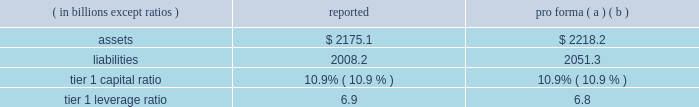Notes to consolidated financial statements 192 jpmorgan chase & co .
/ 2008 annual report consolidation analysis the multi-seller conduits administered by the firm were not consoli- dated at december 31 , 2008 and 2007 , because each conduit had issued expected loss notes ( 201celns 201d ) , the holders of which are com- mitted to absorbing the majority of the expected loss of each respective conduit .
Implied support the firm did not have and continues not to have any intent to pro- tect any eln holders from potential losses on any of the conduits 2019 holdings and has no plans to remove any assets from any conduit unless required to do so in its role as administrator .
Should such a transfer occur , the firm would allocate losses on such assets between itself and the eln holders in accordance with the terms of the applicable eln .
Expected loss modeling in determining the primary beneficiary of the conduits the firm uses a monte carlo 2013based model to estimate the expected losses of each of the conduits and considers the relative rights and obliga- tions of each of the variable interest holders .
The firm 2019s expected loss modeling treats all variable interests , other than the elns , as its own to determine consolidation .
The variability to be considered in the modeling of expected losses is based on the design of the enti- ty .
The firm 2019s traditional multi-seller conduits are designed to pass credit risk , not liquidity risk , to its variable interest holders , as the assets are intended to be held in the conduit for the longer term .
Under fin 46 ( r ) , the firm is required to run the monte carlo-based expected loss model each time a reconsideration event occurs .
In applying this guidance to the conduits , the following events , are considered to be reconsideration events , as they could affect the determination of the primary beneficiary of the conduits : 2022 new deals , including the issuance of new or additional variable interests ( credit support , liquidity facilities , etc ) ; 2022 changes in usage , including the change in the level of outstand- ing variable interests ( credit support , liquidity facilities , etc ) ; 2022 modifications of asset purchase agreements ; and 2022 sales of interests held by the primary beneficiary .
From an operational perspective , the firm does not run its monte carlo-based expected loss model every time there is a reconsideration event due to the frequency of their occurrence .
Instead , the firm runs its expected loss model each quarter and includes a growth assump- tion for each conduit to ensure that a sufficient amount of elns exists for each conduit at any point during the quarter .
As part of its normal quarterly modeling , the firm updates , when applicable , the inputs and assumptions used in the expected loss model .
Specifically , risk ratings and loss given default assumptions are continually updated .
The total amount of expected loss notes out- standing at december 31 , 2008 and 2007 , were $ 136 million and $ 130 million , respectively .
Management has concluded that the model assumptions used were reflective of market participants 2019 assumptions and appropriately considered the probability of changes to risk ratings and loss given defaults .
Qualitative considerations the multi-seller conduits are primarily designed to provide an effi- cient means for clients to access the commercial paper market .
The firm believes the conduits effectively disperse risk among all parties and that the preponderance of the economic risk in the firm 2019s multi- seller conduits is not held by jpmorgan chase .
Consolidated sensitivity analysis on capital the table below shows the impact on the firm 2019s reported assets , lia- bilities , tier 1 capital ratio and tier 1 leverage ratio if the firm were required to consolidate all of the multi-seller conduits that it admin- isters at their current carrying value .
December 31 , 2008 ( in billions , except ratios ) reported pro forma ( a ) ( b ) .
( a ) the table shows the impact of consolidating the assets and liabilities of the multi- seller conduits at their current carrying value ; as such , there would be no income statement or capital impact at the date of consolidation .
If the firm were required to consolidate the assets and liabilities of the conduits at fair value , the tier 1 capital ratio would be approximately 10.8% ( 10.8 % ) .
The fair value of the assets is primarily based upon pricing for comparable transactions .
The fair value of these assets could change significantly because the pricing of conduit transactions is renegotiated with the client , generally , on an annual basis and due to changes in current market conditions .
( b ) consolidation is assumed to occur on the first day of the quarter , at the quarter-end levels , in order to provide a meaningful adjustment to average assets in the denomi- nator of the leverage ratio .
The firm could fund purchases of assets from vies should it become necessary .
2007 activity in july 2007 , a reverse repurchase agreement collateralized by prime residential mortgages held by a firm-administered multi-seller conduit was put to jpmorgan chase under its deal-specific liquidity facility .
The asset was transferred to and recorded by jpmorgan chase at its par value based on the fair value of the collateral that supported the reverse repurchase agreement .
During the fourth quarter of 2007 , additional information regarding the value of the collateral , including performance statistics , resulted in the determi- nation by the firm that the fair value of the collateral was impaired .
Impairment losses were allocated to the eln holder ( the party that absorbs the majority of the expected loss from the conduit ) in accor- dance with the contractual provisions of the eln note .
On october 29 , 2007 , certain structured cdo assets originated in the second quarter of 2007 and backed by subprime mortgages were transferred to the firm from two firm-administered multi-seller conduits .
It became clear in october that commercial paper investors and rating agencies were becoming increasingly concerned about cdo assets backed by subprime mortgage exposures .
Because of these concerns , and to ensure the continuing viability of the two conduits as financing vehicles for clients and as investment alternatives for commercial paper investors , the firm , in its role as administrator , transferred the cdo assets out of the multi-seller con- duits .
The structured cdo assets were transferred to the firm at .
What was the ratio of the total amount of expected loss notes out- standing at december 31 , 2008 compared to 2007? 
Computations: (136 / 130)
Answer: 1.04615. 